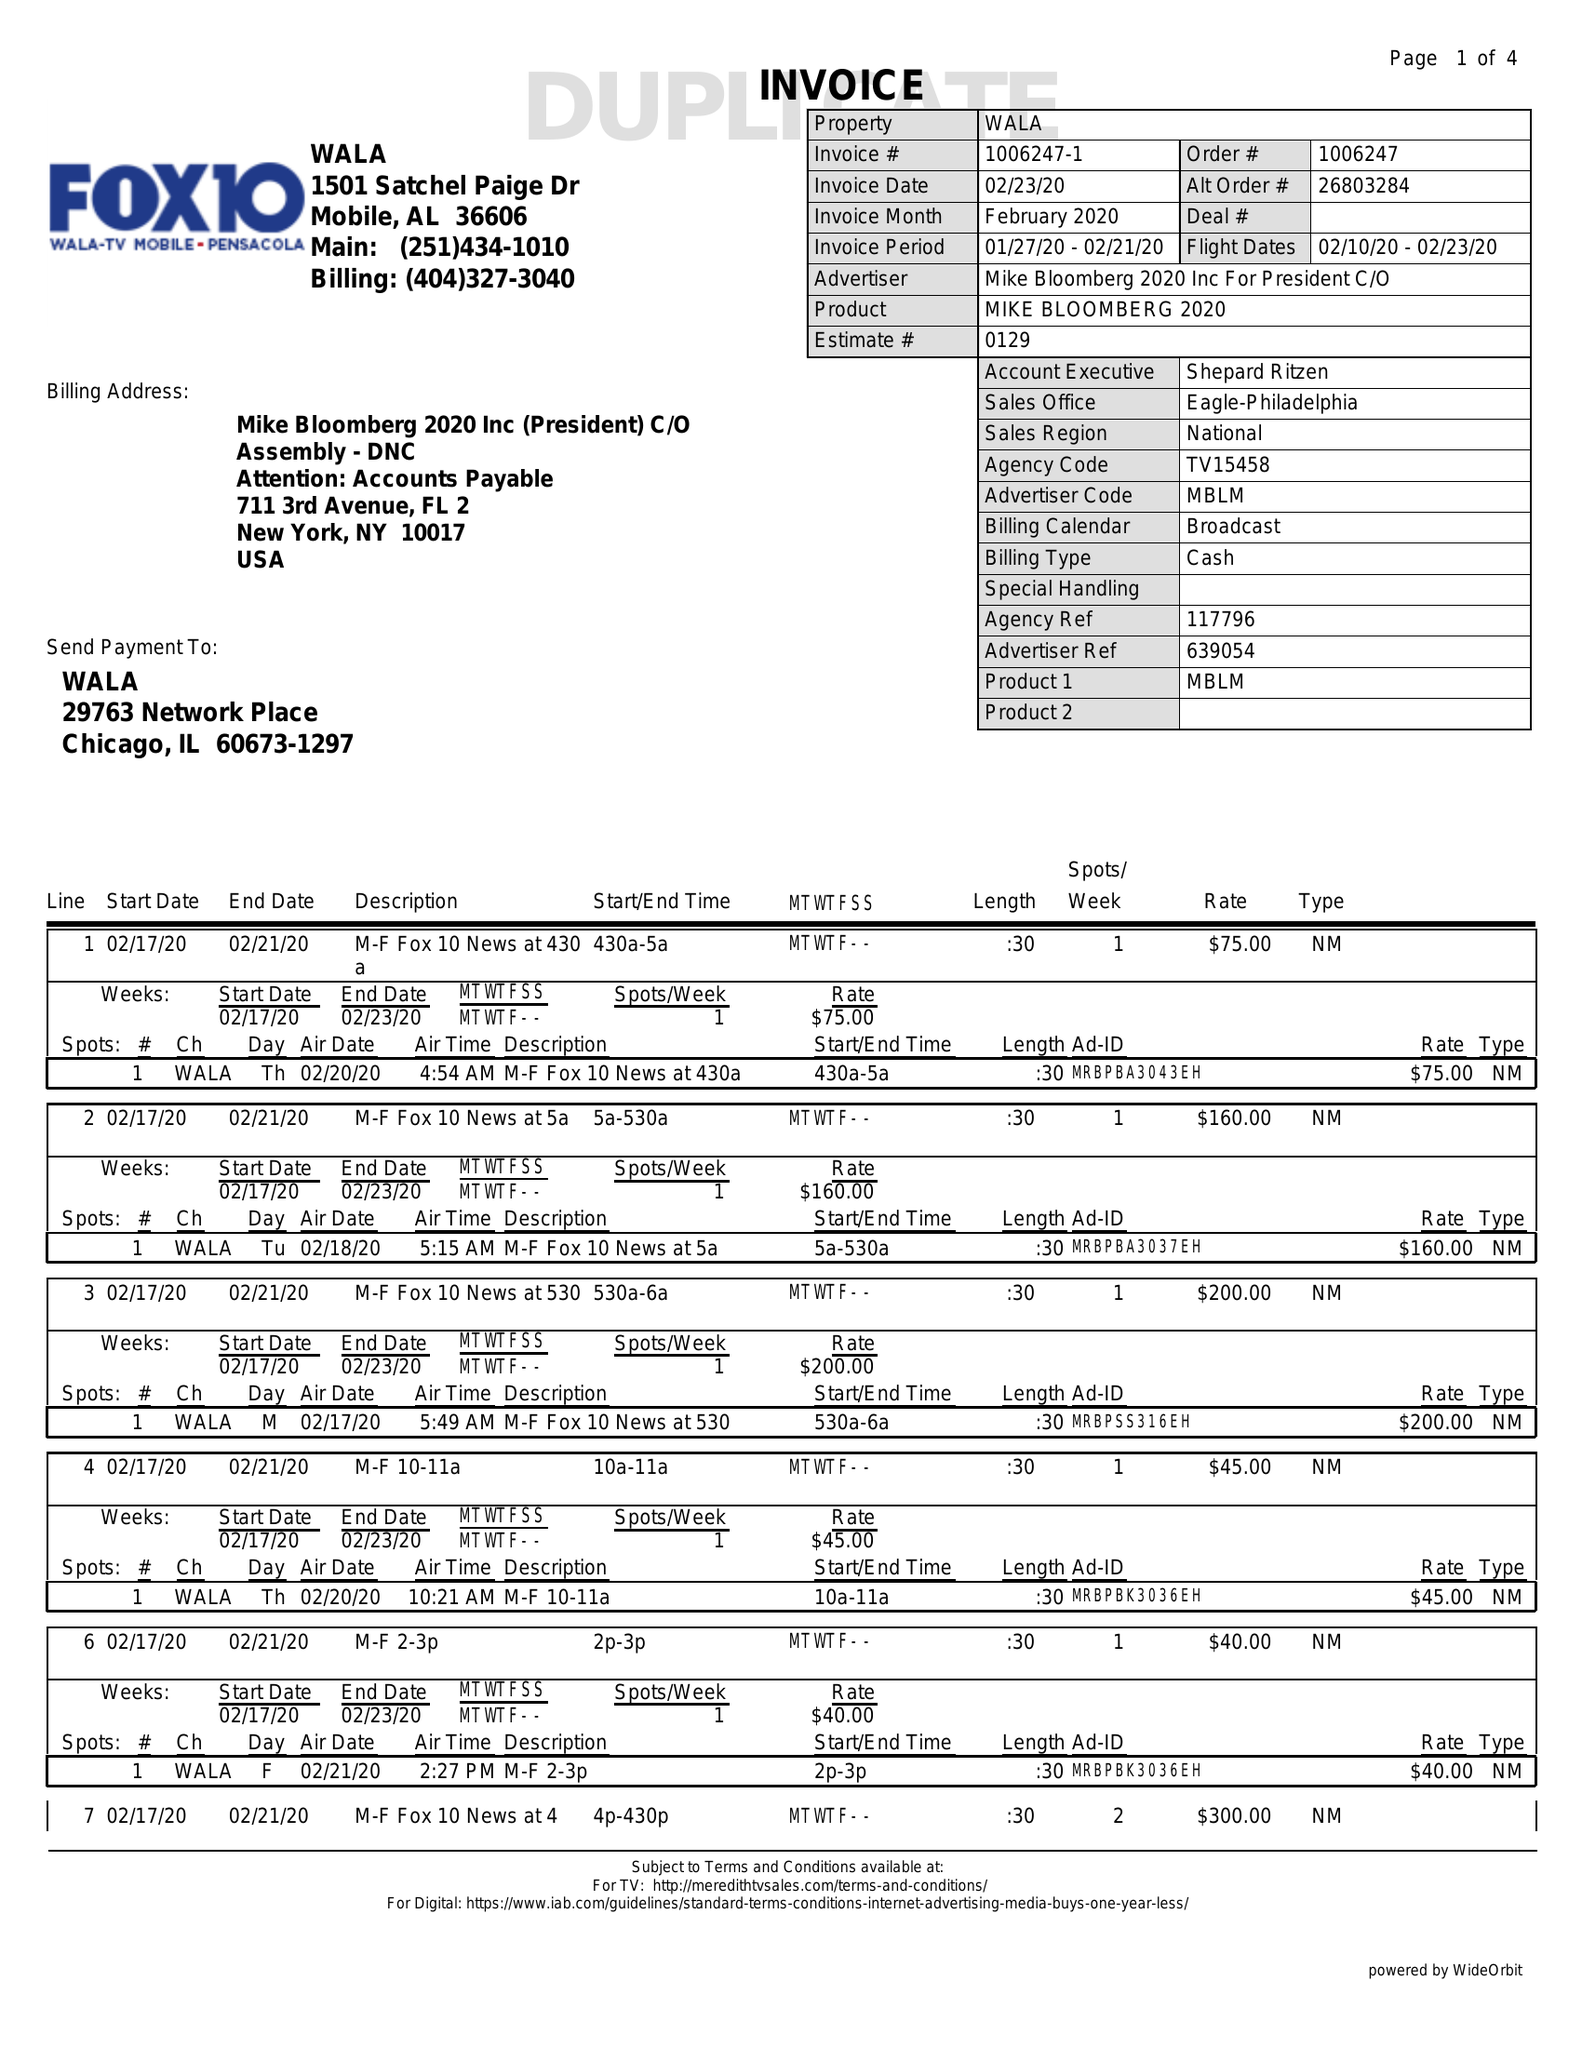What is the value for the flight_from?
Answer the question using a single word or phrase. 02/10/20 